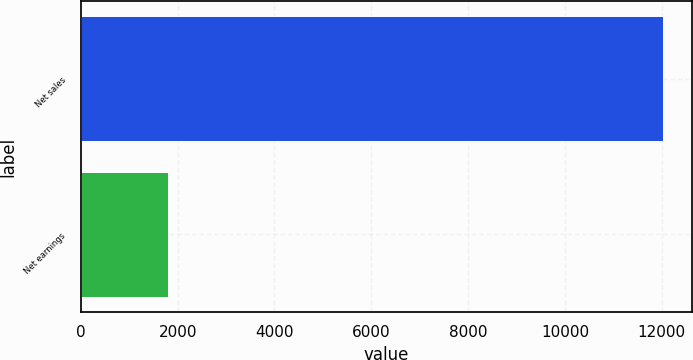Convert chart. <chart><loc_0><loc_0><loc_500><loc_500><bar_chart><fcel>Net sales<fcel>Net earnings<nl><fcel>12033<fcel>1796<nl></chart> 